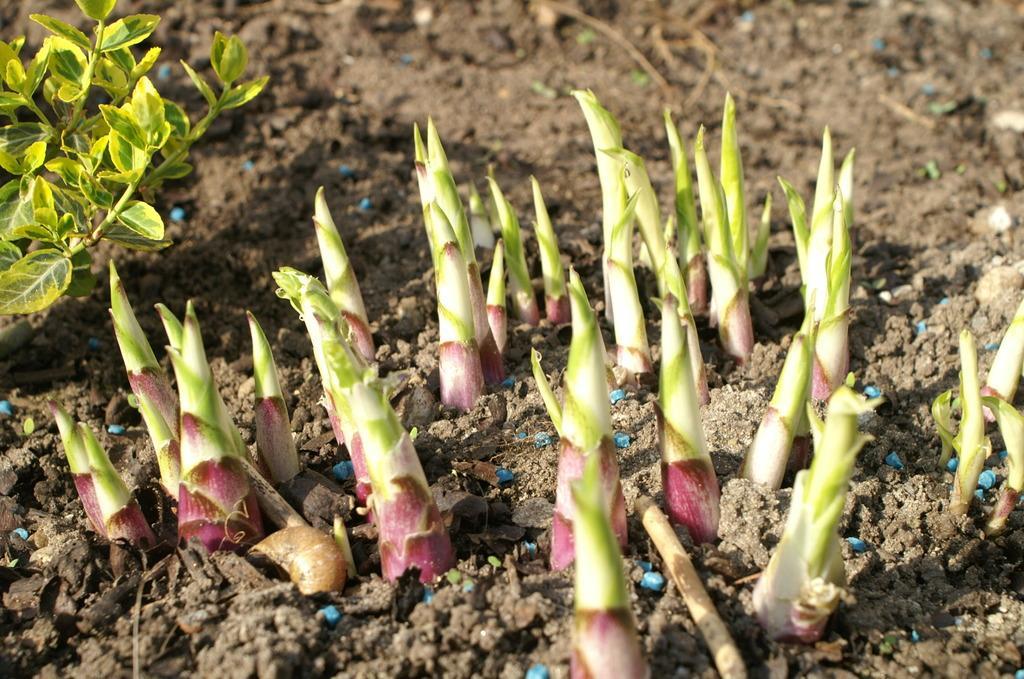Can you describe this image briefly? In this image there are small sprouts coming out from the soil. On the left side there is a plant. 